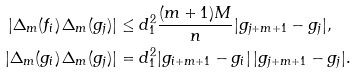<formula> <loc_0><loc_0><loc_500><loc_500>| \Delta _ { m } ( f _ { i } ) \, \Delta _ { m } ( g _ { j } ) | & \leq d _ { 1 } ^ { 2 } \frac { ( m + 1 ) M } { n } | g _ { j + m + 1 } - g _ { j } | , \\ | \Delta _ { m } ( g _ { i } ) \, \Delta _ { m } ( g _ { j } ) | & = d _ { 1 } ^ { 2 } | g _ { i + m + 1 } - g _ { i } | \, | g _ { j + m + 1 } - g _ { j } | .</formula> 